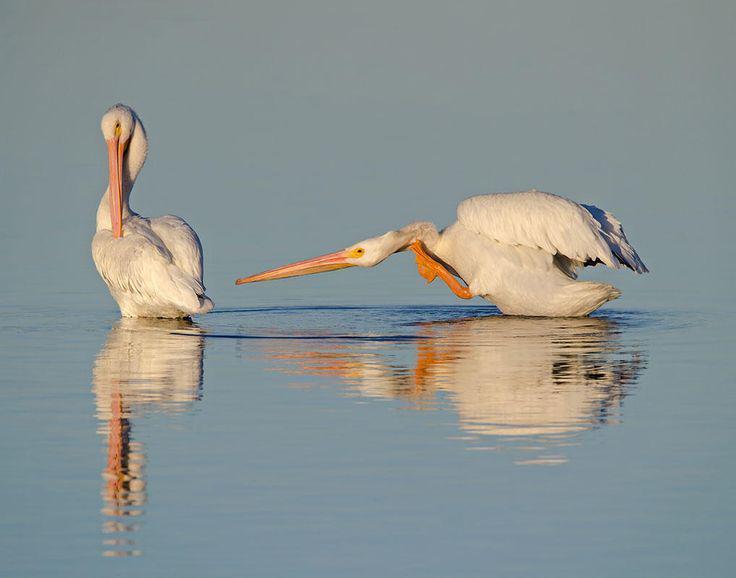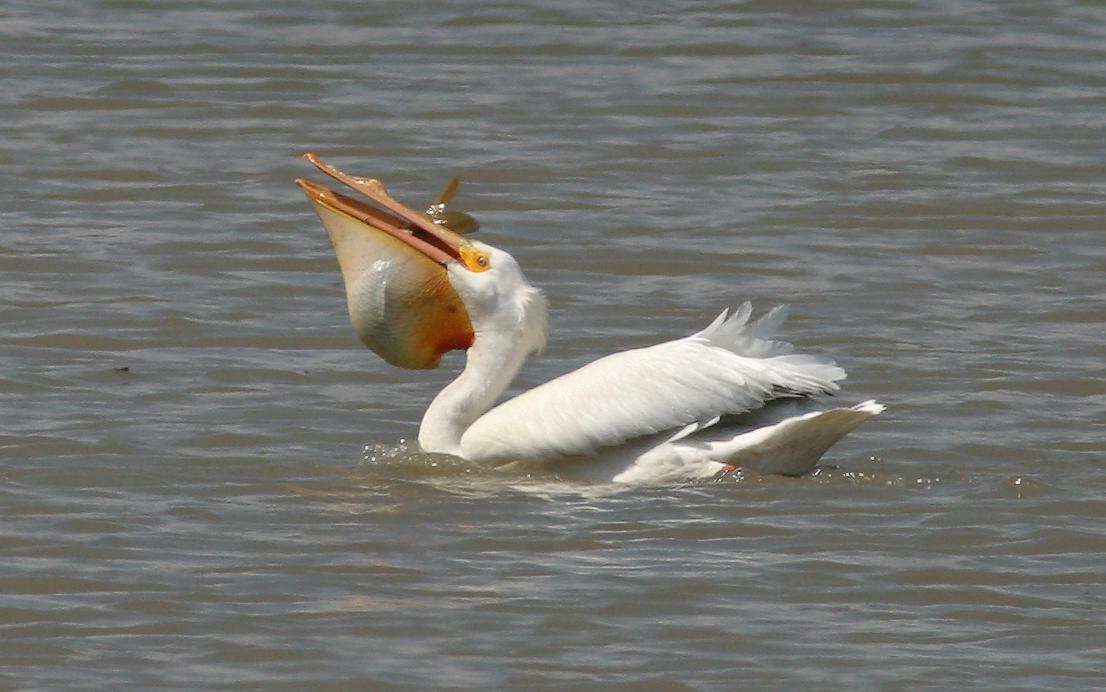The first image is the image on the left, the second image is the image on the right. Examine the images to the left and right. Is the description "The left image shows two pelicans on the water." accurate? Answer yes or no. Yes. 